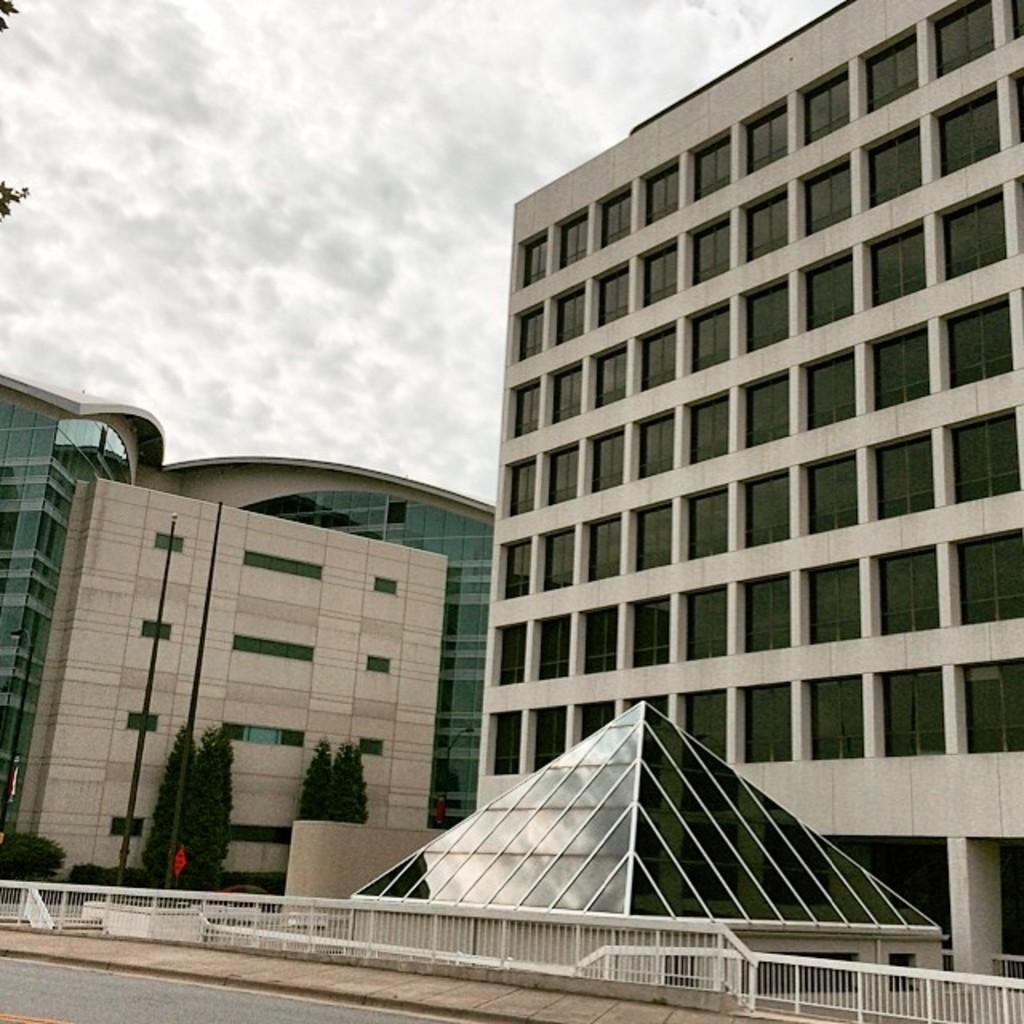What is in the foreground of the image? In the foreground of the image, there is a road, a railing, buildings, and trees. Can you describe the sky in the image? The sky is visible at the top of the image. Is your friend standing next to the mailbox in the image? There is no mention of a friend or a mailbox in the image, so we cannot answer this question. 